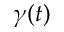<formula> <loc_0><loc_0><loc_500><loc_500>\gamma ( t )</formula> 